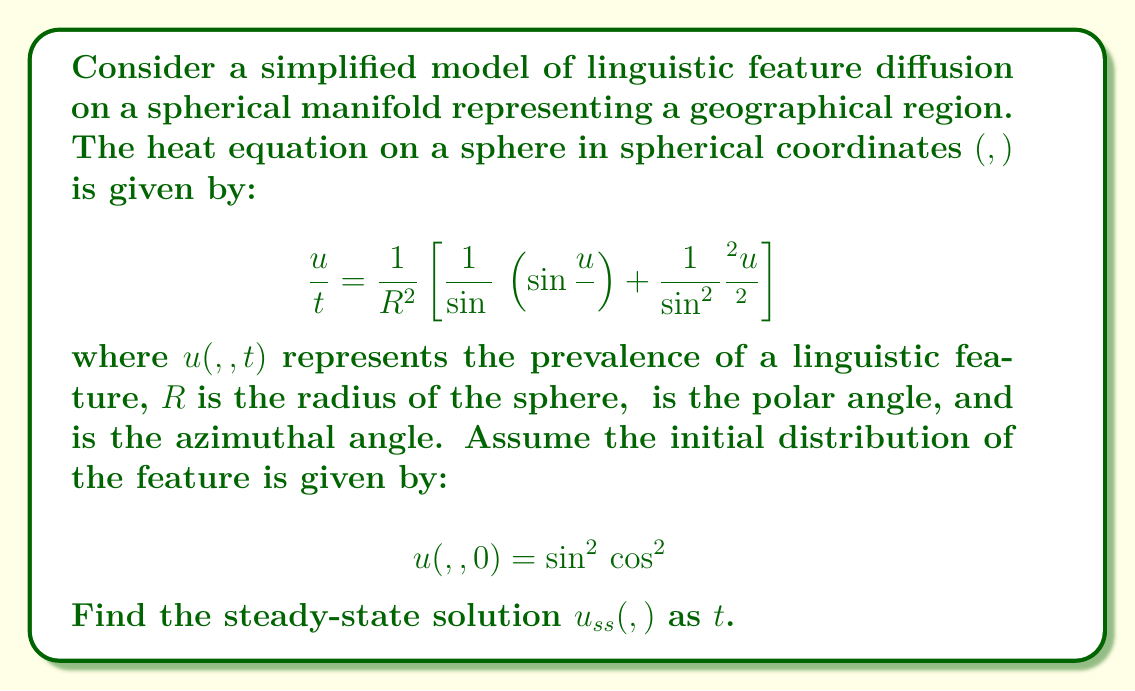Solve this math problem. To find the steady-state solution, we follow these steps:

1) The steady-state solution is independent of time, so $\frac{∂u}{∂t} = 0$. This reduces the heat equation to:

   $$0 = \frac{1}{R^2} \left[\frac{1}{\sin θ} \frac{∂}{∂θ} \left(\sin θ \frac{∂u_{ss}}{∂θ}\right) + \frac{1}{\sin^2 θ} \frac{∂^2u_{ss}}{∂φ^2}\right]$$

2) For a sphere, the steady-state solution is a constant value, which is the average of the initial distribution over the entire sphere. This is because heat (or in this case, the linguistic feature) will eventually spread evenly across the entire surface.

3) To find this average, we integrate the initial distribution over the sphere and divide by the surface area:

   $$u_{ss} = \frac{\int_0^{2π} \int_0^π u(θ, φ, 0) \sin θ \, dθ \, dφ}{4πR^2}$$

4) Substituting the initial distribution:

   $$u_{ss} = \frac{\int_0^{2π} \int_0^π \sin^2 θ \cos^2 φ \sin θ \, dθ \, dφ}{4πR^2}$$

5) Evaluate the φ integral first:

   $$\int_0^{2π} \cos^2 φ \, dφ = π$$

6) Then evaluate the θ integral:

   $$\int_0^π \sin^3 θ \, dθ = \frac{4}{3}$$

7) Combining these results:

   $$u_{ss} = \frac{π \cdot \frac{4}{3}}{4πR^2} = \frac{1}{3R^2}$$

Therefore, the steady-state solution is a constant value independent of θ and φ.
Answer: $u_{ss}(θ, φ) = \frac{1}{3R^2}$ 